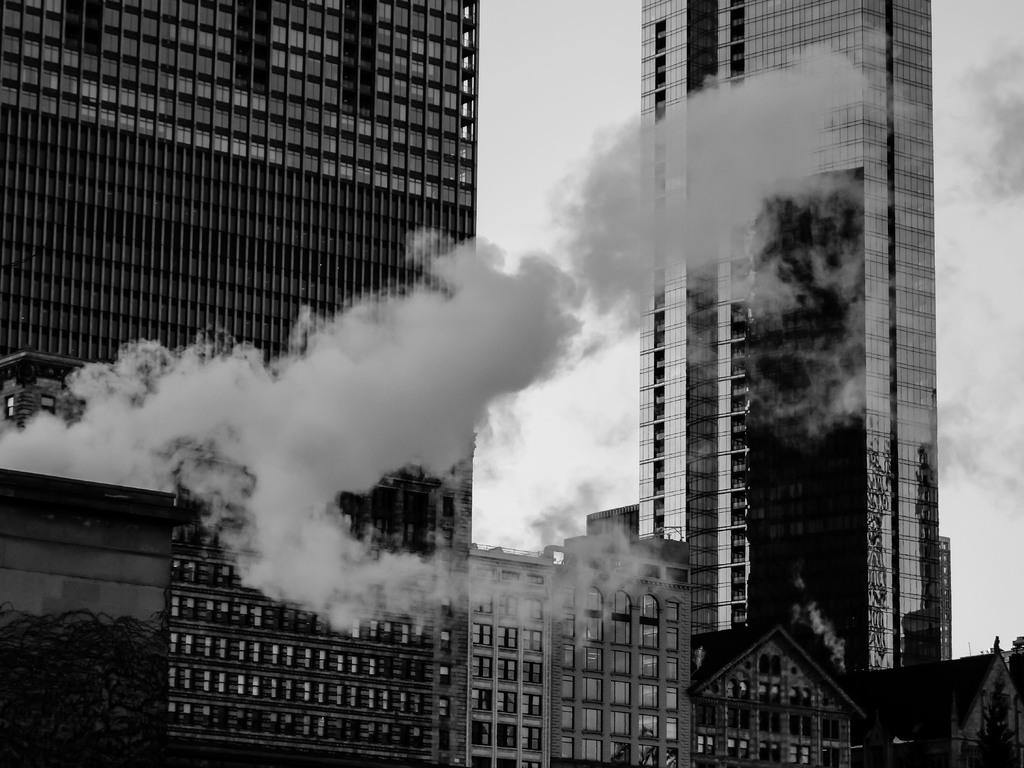What type of structures can be seen in the image? There are buildings in the image. What environmental issue is visible in the image? Air pollution is visible in the image. What can be seen in the sky behind the buildings? There are clouds in the sky behind the buildings. How many pieces of pie can be seen on the windowsill of the buildings in the image? There is no pie visible on the windowsill of the buildings in the image. What type of animals can be seen hopping around the buildings in the image? There are no rabbits or chickens present in the image. 